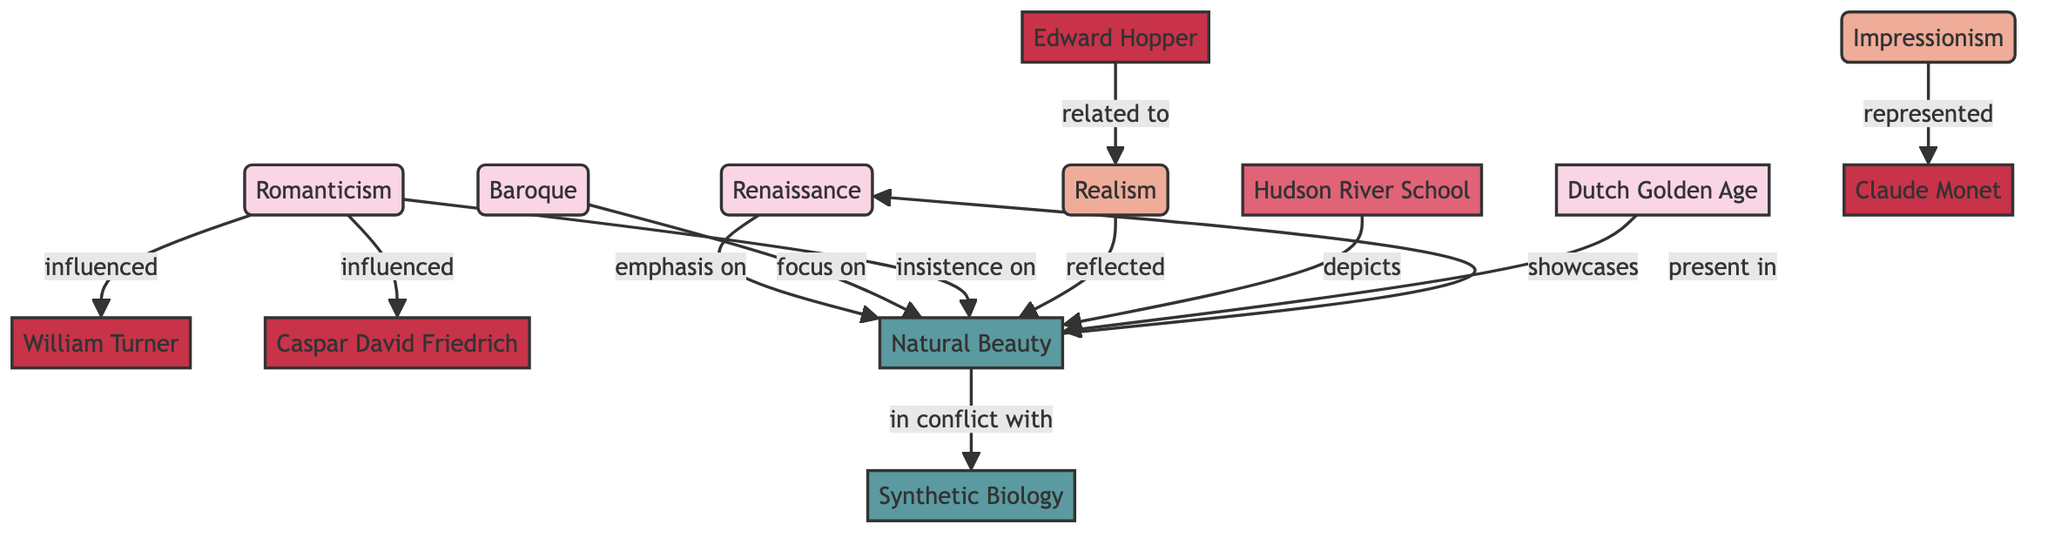What historical movement emphasizes Natural Beauty? According to the diagram, the Renaissance is directly linked to Natural Beauty with the label "emphasis on." This indicates that the Renaissance is a historical movement that significantly values Natural Beauty.
Answer: Renaissance Which artist did Romanticism influence? The diagram shows that Romanticism influenced both William Turner and Caspar David Friedrich. Thus, either artist can be the answer, but focusing on just one, I'll choose William Turner.
Answer: William Turner How many nodes are classified under the "Historical Movement" group? In the diagram, the nodes labeled as Historical Movement are Renaissance, Baroque, Romanticism, and Dutch Golden Age. Counting these reveals a total of four nodes in this category.
Answer: 4 What concept is in conflict with Natural Beauty? The diagram explicitly shows a relationship between Natural Beauty and Synthetic Biology, with the label "in conflict with." This indicates that Synthetic Biology stands opposed to the idea of Natural Beauty within the context of the diagram.
Answer: Synthetic Biology Which movement reflects Natural Beauty? From the edges connecting to the Natural Beauty node, Realism is linked with the label "reflected." This means that Realism is a modern movement that incorporates or showcases aspects of Natural Beauty in its work.
Answer: Realism How many edges connect to the Natural Beauty node? In the diagram, Natural Beauty has multiple connections: it is connected to Renaissance, Baroque, Romanticism, Realism, Hudson River School, and Dutch Golden Age. This totals to six edges linked to Natural Beauty.
Answer: 6 What is the relationship between Edward Hopper and Realism? The diagram indicates that Edward Hopper is related to Realism by the connection labeled "related to." This shows that Hopper's work is associated with or linked to the characteristics of Realism.
Answer: related to Which modern movement is represented by Claude Monet? The edge labeled "represented" connects Impressionism to Claude Monet. This clarifies that Claude Monet is a significant representative of the Impressionism movement within the diagram.
Answer: Impressionism What does the Dutch Golden Age showcase? The diagram links the Dutch Golden Age to Natural Beauty with the label "showcases." This explicitly states that the art produced during the Dutch Golden Age is characterized by its depiction of Natural Beauty.
Answer: Natural Beauty 